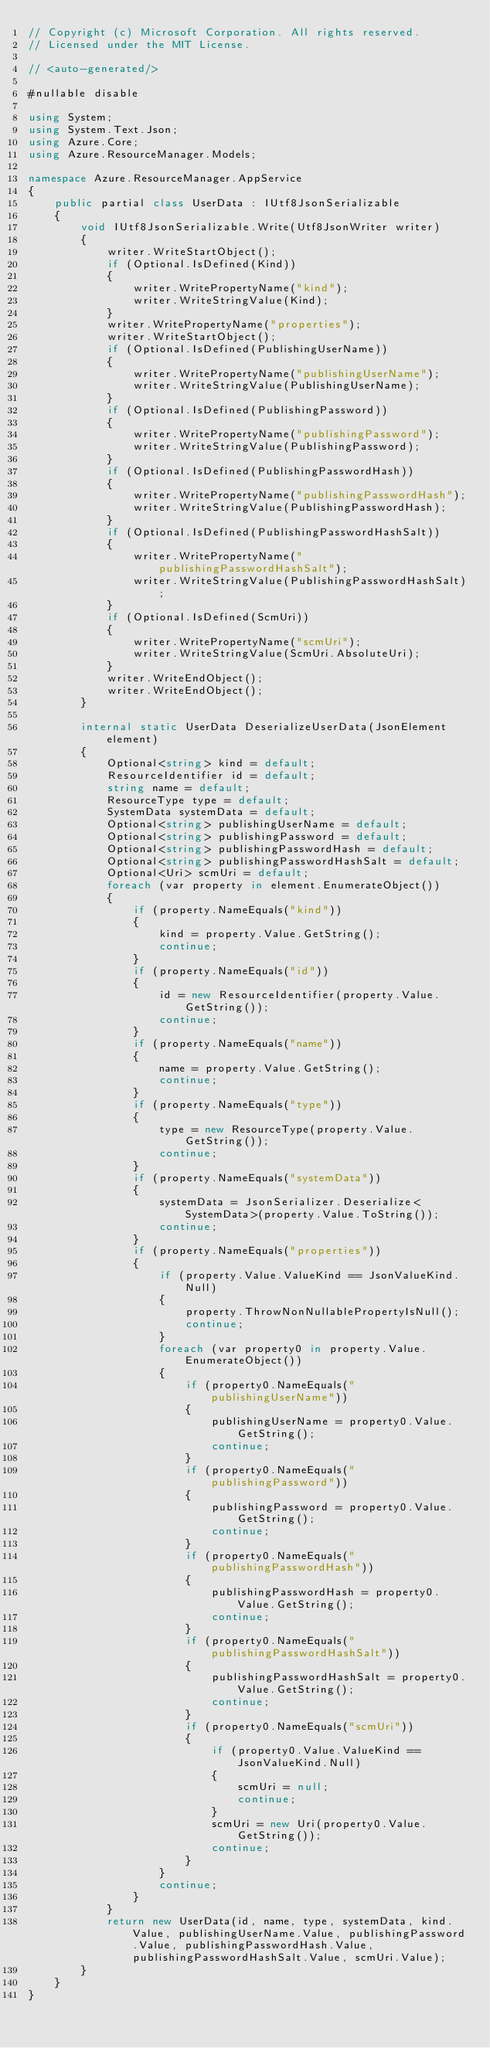Convert code to text. <code><loc_0><loc_0><loc_500><loc_500><_C#_>// Copyright (c) Microsoft Corporation. All rights reserved.
// Licensed under the MIT License.

// <auto-generated/>

#nullable disable

using System;
using System.Text.Json;
using Azure.Core;
using Azure.ResourceManager.Models;

namespace Azure.ResourceManager.AppService
{
    public partial class UserData : IUtf8JsonSerializable
    {
        void IUtf8JsonSerializable.Write(Utf8JsonWriter writer)
        {
            writer.WriteStartObject();
            if (Optional.IsDefined(Kind))
            {
                writer.WritePropertyName("kind");
                writer.WriteStringValue(Kind);
            }
            writer.WritePropertyName("properties");
            writer.WriteStartObject();
            if (Optional.IsDefined(PublishingUserName))
            {
                writer.WritePropertyName("publishingUserName");
                writer.WriteStringValue(PublishingUserName);
            }
            if (Optional.IsDefined(PublishingPassword))
            {
                writer.WritePropertyName("publishingPassword");
                writer.WriteStringValue(PublishingPassword);
            }
            if (Optional.IsDefined(PublishingPasswordHash))
            {
                writer.WritePropertyName("publishingPasswordHash");
                writer.WriteStringValue(PublishingPasswordHash);
            }
            if (Optional.IsDefined(PublishingPasswordHashSalt))
            {
                writer.WritePropertyName("publishingPasswordHashSalt");
                writer.WriteStringValue(PublishingPasswordHashSalt);
            }
            if (Optional.IsDefined(ScmUri))
            {
                writer.WritePropertyName("scmUri");
                writer.WriteStringValue(ScmUri.AbsoluteUri);
            }
            writer.WriteEndObject();
            writer.WriteEndObject();
        }

        internal static UserData DeserializeUserData(JsonElement element)
        {
            Optional<string> kind = default;
            ResourceIdentifier id = default;
            string name = default;
            ResourceType type = default;
            SystemData systemData = default;
            Optional<string> publishingUserName = default;
            Optional<string> publishingPassword = default;
            Optional<string> publishingPasswordHash = default;
            Optional<string> publishingPasswordHashSalt = default;
            Optional<Uri> scmUri = default;
            foreach (var property in element.EnumerateObject())
            {
                if (property.NameEquals("kind"))
                {
                    kind = property.Value.GetString();
                    continue;
                }
                if (property.NameEquals("id"))
                {
                    id = new ResourceIdentifier(property.Value.GetString());
                    continue;
                }
                if (property.NameEquals("name"))
                {
                    name = property.Value.GetString();
                    continue;
                }
                if (property.NameEquals("type"))
                {
                    type = new ResourceType(property.Value.GetString());
                    continue;
                }
                if (property.NameEquals("systemData"))
                {
                    systemData = JsonSerializer.Deserialize<SystemData>(property.Value.ToString());
                    continue;
                }
                if (property.NameEquals("properties"))
                {
                    if (property.Value.ValueKind == JsonValueKind.Null)
                    {
                        property.ThrowNonNullablePropertyIsNull();
                        continue;
                    }
                    foreach (var property0 in property.Value.EnumerateObject())
                    {
                        if (property0.NameEquals("publishingUserName"))
                        {
                            publishingUserName = property0.Value.GetString();
                            continue;
                        }
                        if (property0.NameEquals("publishingPassword"))
                        {
                            publishingPassword = property0.Value.GetString();
                            continue;
                        }
                        if (property0.NameEquals("publishingPasswordHash"))
                        {
                            publishingPasswordHash = property0.Value.GetString();
                            continue;
                        }
                        if (property0.NameEquals("publishingPasswordHashSalt"))
                        {
                            publishingPasswordHashSalt = property0.Value.GetString();
                            continue;
                        }
                        if (property0.NameEquals("scmUri"))
                        {
                            if (property0.Value.ValueKind == JsonValueKind.Null)
                            {
                                scmUri = null;
                                continue;
                            }
                            scmUri = new Uri(property0.Value.GetString());
                            continue;
                        }
                    }
                    continue;
                }
            }
            return new UserData(id, name, type, systemData, kind.Value, publishingUserName.Value, publishingPassword.Value, publishingPasswordHash.Value, publishingPasswordHashSalt.Value, scmUri.Value);
        }
    }
}
</code> 